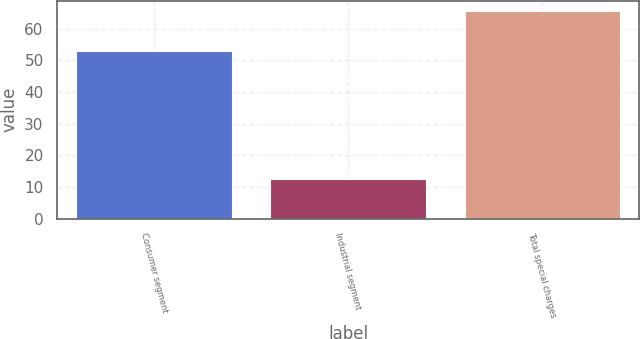<chart> <loc_0><loc_0><loc_500><loc_500><bar_chart><fcel>Consumer segment<fcel>Industrial segment<fcel>Total special charges<nl><fcel>52.8<fcel>12.7<fcel>65.5<nl></chart> 